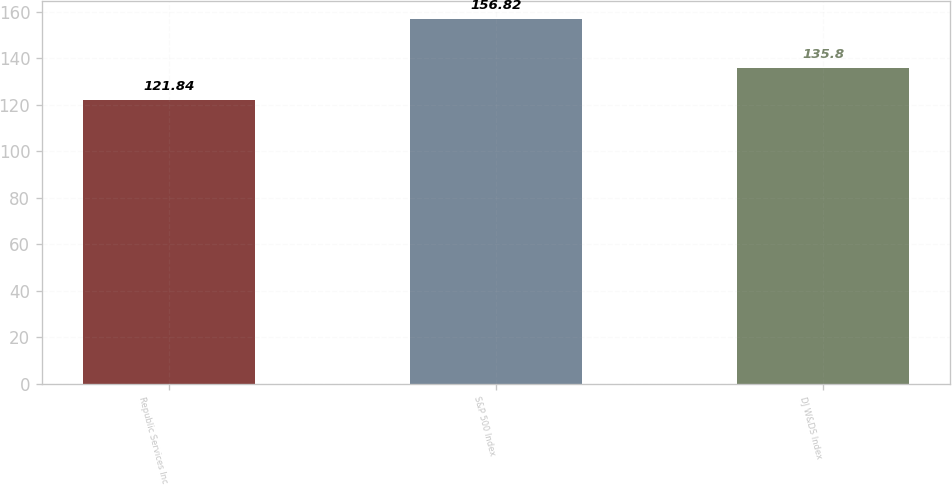<chart> <loc_0><loc_0><loc_500><loc_500><bar_chart><fcel>Republic Services Inc<fcel>S&P 500 Index<fcel>DJ W&DS Index<nl><fcel>121.84<fcel>156.82<fcel>135.8<nl></chart> 